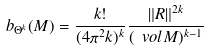Convert formula to latex. <formula><loc_0><loc_0><loc_500><loc_500>b _ { \Theta ^ { k } } ( M ) = \frac { k ! } { ( 4 \pi ^ { 2 } k ) ^ { k } } \frac { \| R \| ^ { 2 k } } { ( \ v o l M ) ^ { k - 1 } }</formula> 